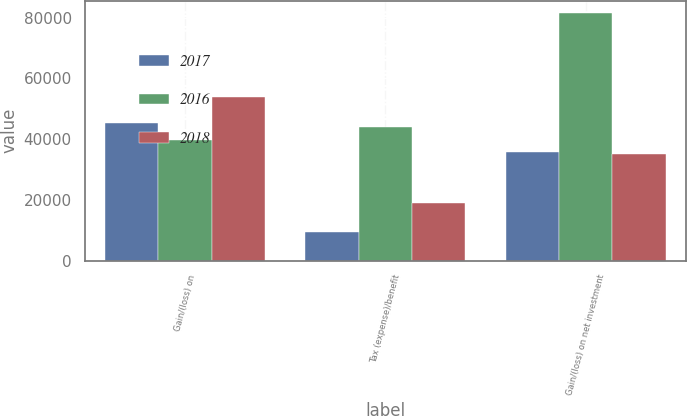Convert chart to OTSL. <chart><loc_0><loc_0><loc_500><loc_500><stacked_bar_chart><ecel><fcel>Gain/(loss) on<fcel>Tax (expense)/benefit<fcel>Gain/(loss) on net investment<nl><fcel>2017<fcel>45230<fcel>9498<fcel>35732<nl><fcel>2016<fcel>39787<fcel>43842<fcel>81420<nl><fcel>2018<fcel>53791<fcel>18827<fcel>34964<nl></chart> 